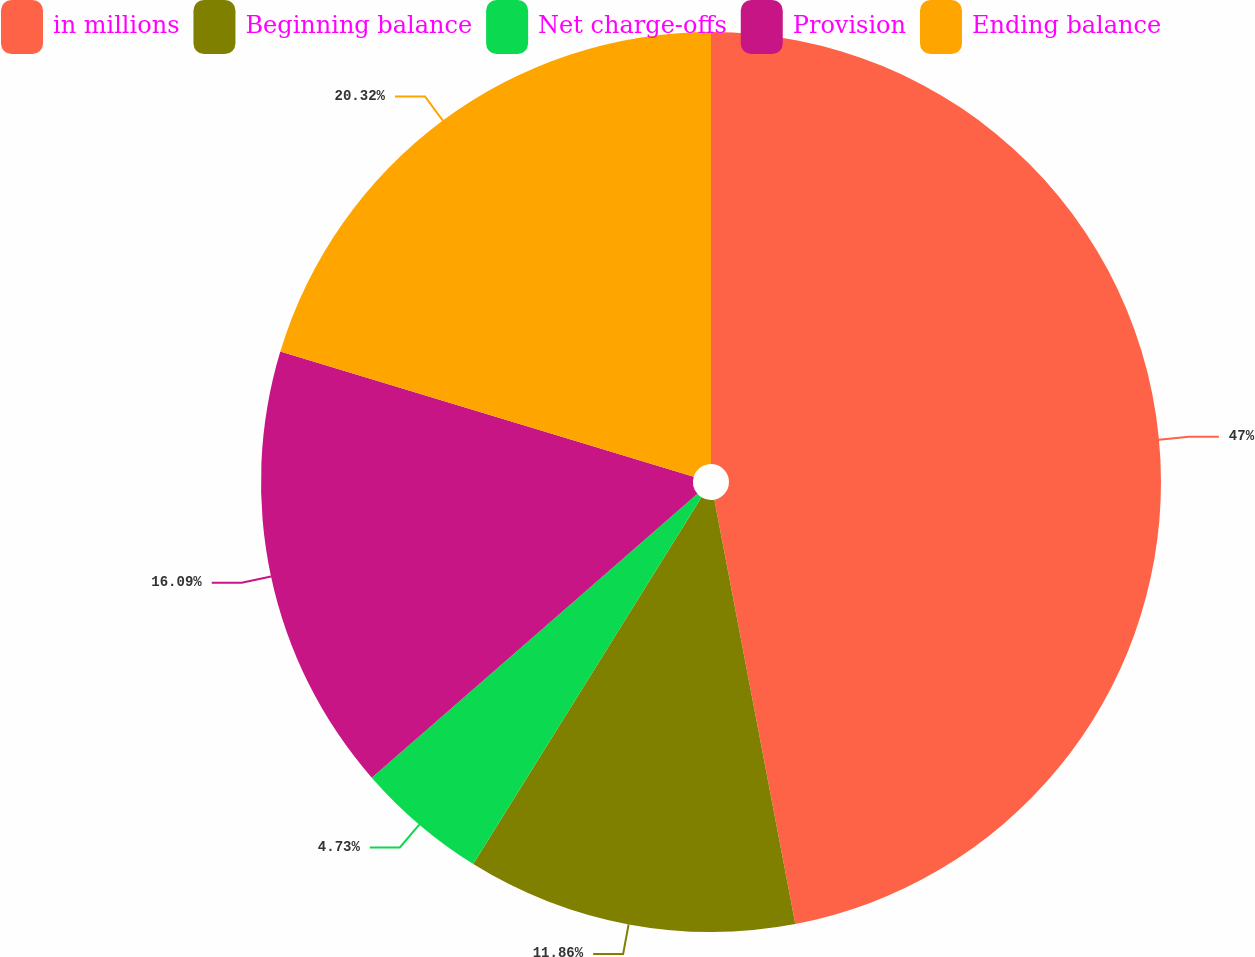Convert chart. <chart><loc_0><loc_0><loc_500><loc_500><pie_chart><fcel>in millions<fcel>Beginning balance<fcel>Net charge-offs<fcel>Provision<fcel>Ending balance<nl><fcel>47.0%<fcel>11.86%<fcel>4.73%<fcel>16.09%<fcel>20.32%<nl></chart> 